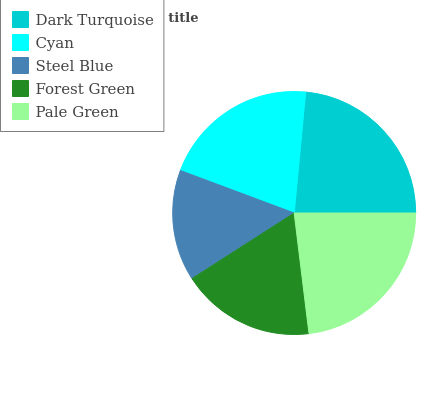Is Steel Blue the minimum?
Answer yes or no. Yes. Is Dark Turquoise the maximum?
Answer yes or no. Yes. Is Cyan the minimum?
Answer yes or no. No. Is Cyan the maximum?
Answer yes or no. No. Is Dark Turquoise greater than Cyan?
Answer yes or no. Yes. Is Cyan less than Dark Turquoise?
Answer yes or no. Yes. Is Cyan greater than Dark Turquoise?
Answer yes or no. No. Is Dark Turquoise less than Cyan?
Answer yes or no. No. Is Cyan the high median?
Answer yes or no. Yes. Is Cyan the low median?
Answer yes or no. Yes. Is Pale Green the high median?
Answer yes or no. No. Is Steel Blue the low median?
Answer yes or no. No. 